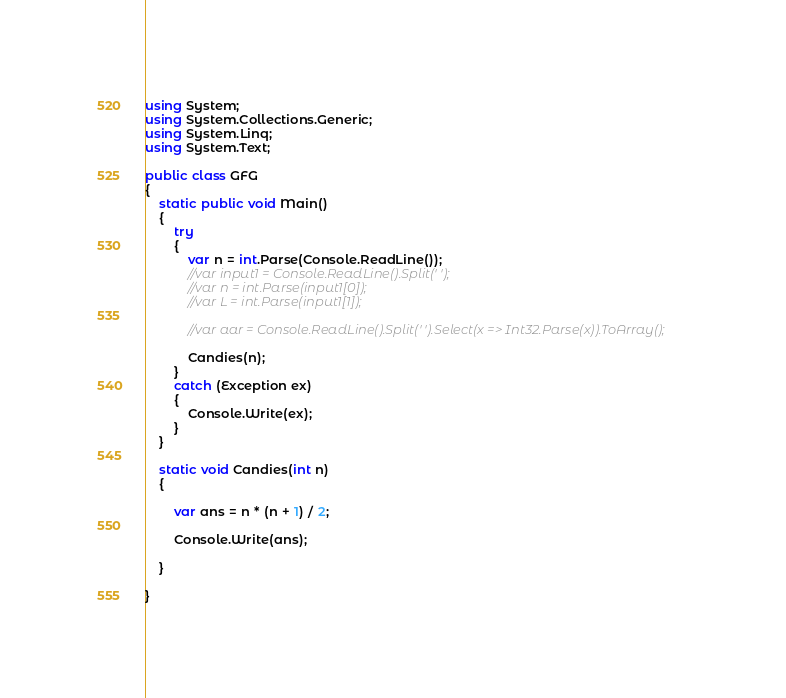<code> <loc_0><loc_0><loc_500><loc_500><_C#_>using System;
using System.Collections.Generic;
using System.Linq;
using System.Text;

public class GFG
{
    static public void Main()
    {
        try
        {
            var n = int.Parse(Console.ReadLine());
            //var input1 = Console.ReadLine().Split(' ');
            //var n = int.Parse(input1[0]);
            //var L = int.Parse(input1[1]);

            //var aar = Console.ReadLine().Split(' ').Select(x => Int32.Parse(x)).ToArray();

            Candies(n);
        }
        catch (Exception ex)
        {
            Console.Write(ex);
        }
    }

    static void Candies(int n)
    {

        var ans = n * (n + 1) / 2;

        Console.Write(ans);

    }

}</code> 